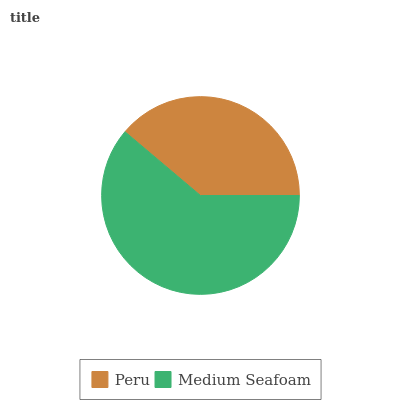Is Peru the minimum?
Answer yes or no. Yes. Is Medium Seafoam the maximum?
Answer yes or no. Yes. Is Medium Seafoam the minimum?
Answer yes or no. No. Is Medium Seafoam greater than Peru?
Answer yes or no. Yes. Is Peru less than Medium Seafoam?
Answer yes or no. Yes. Is Peru greater than Medium Seafoam?
Answer yes or no. No. Is Medium Seafoam less than Peru?
Answer yes or no. No. Is Medium Seafoam the high median?
Answer yes or no. Yes. Is Peru the low median?
Answer yes or no. Yes. Is Peru the high median?
Answer yes or no. No. Is Medium Seafoam the low median?
Answer yes or no. No. 